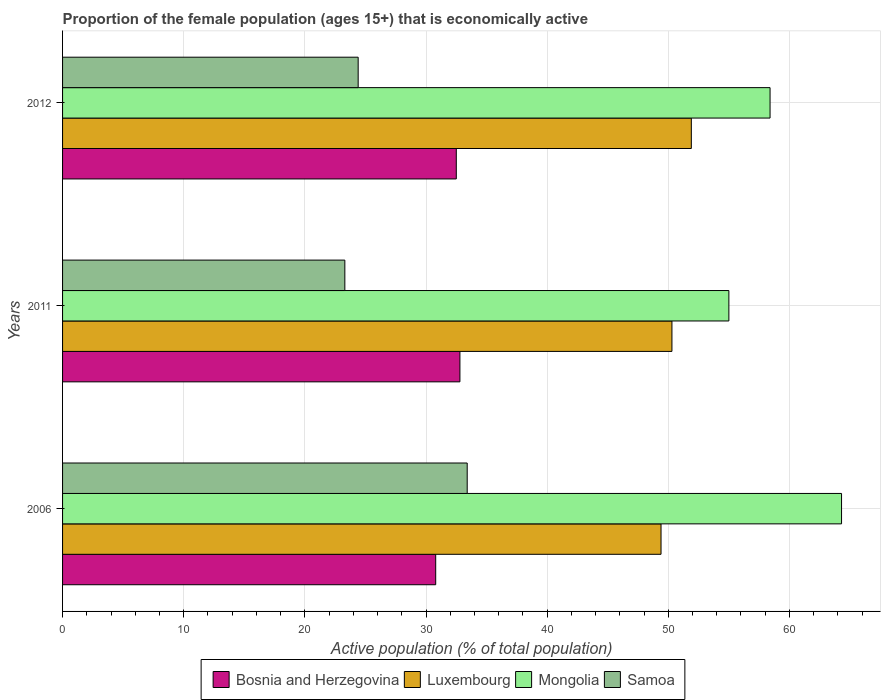How many different coloured bars are there?
Provide a short and direct response. 4. Are the number of bars per tick equal to the number of legend labels?
Your answer should be very brief. Yes. Are the number of bars on each tick of the Y-axis equal?
Keep it short and to the point. Yes. How many bars are there on the 1st tick from the bottom?
Offer a very short reply. 4. What is the label of the 3rd group of bars from the top?
Offer a terse response. 2006. What is the proportion of the female population that is economically active in Luxembourg in 2012?
Give a very brief answer. 51.9. Across all years, what is the maximum proportion of the female population that is economically active in Mongolia?
Your answer should be very brief. 64.3. Across all years, what is the minimum proportion of the female population that is economically active in Bosnia and Herzegovina?
Your answer should be very brief. 30.8. In which year was the proportion of the female population that is economically active in Samoa maximum?
Your response must be concise. 2006. What is the total proportion of the female population that is economically active in Bosnia and Herzegovina in the graph?
Your response must be concise. 96.1. What is the difference between the proportion of the female population that is economically active in Mongolia in 2006 and that in 2012?
Your answer should be compact. 5.9. What is the average proportion of the female population that is economically active in Bosnia and Herzegovina per year?
Keep it short and to the point. 32.03. In the year 2006, what is the difference between the proportion of the female population that is economically active in Samoa and proportion of the female population that is economically active in Luxembourg?
Offer a terse response. -16. What is the ratio of the proportion of the female population that is economically active in Luxembourg in 2006 to that in 2012?
Keep it short and to the point. 0.95. Is the proportion of the female population that is economically active in Bosnia and Herzegovina in 2006 less than that in 2011?
Make the answer very short. Yes. Is the difference between the proportion of the female population that is economically active in Samoa in 2011 and 2012 greater than the difference between the proportion of the female population that is economically active in Luxembourg in 2011 and 2012?
Your answer should be compact. Yes. What is the difference between the highest and the second highest proportion of the female population that is economically active in Luxembourg?
Your response must be concise. 1.6. What is the difference between the highest and the lowest proportion of the female population that is economically active in Bosnia and Herzegovina?
Keep it short and to the point. 2. What does the 1st bar from the top in 2011 represents?
Your response must be concise. Samoa. What does the 4th bar from the bottom in 2011 represents?
Offer a very short reply. Samoa. Is it the case that in every year, the sum of the proportion of the female population that is economically active in Samoa and proportion of the female population that is economically active in Luxembourg is greater than the proportion of the female population that is economically active in Bosnia and Herzegovina?
Keep it short and to the point. Yes. How many years are there in the graph?
Provide a succinct answer. 3. What is the difference between two consecutive major ticks on the X-axis?
Ensure brevity in your answer.  10. Are the values on the major ticks of X-axis written in scientific E-notation?
Offer a terse response. No. Where does the legend appear in the graph?
Offer a very short reply. Bottom center. How many legend labels are there?
Give a very brief answer. 4. How are the legend labels stacked?
Ensure brevity in your answer.  Horizontal. What is the title of the graph?
Make the answer very short. Proportion of the female population (ages 15+) that is economically active. What is the label or title of the X-axis?
Your answer should be very brief. Active population (% of total population). What is the Active population (% of total population) of Bosnia and Herzegovina in 2006?
Give a very brief answer. 30.8. What is the Active population (% of total population) of Luxembourg in 2006?
Provide a succinct answer. 49.4. What is the Active population (% of total population) in Mongolia in 2006?
Your response must be concise. 64.3. What is the Active population (% of total population) of Samoa in 2006?
Offer a very short reply. 33.4. What is the Active population (% of total population) in Bosnia and Herzegovina in 2011?
Ensure brevity in your answer.  32.8. What is the Active population (% of total population) of Luxembourg in 2011?
Your response must be concise. 50.3. What is the Active population (% of total population) in Samoa in 2011?
Provide a succinct answer. 23.3. What is the Active population (% of total population) of Bosnia and Herzegovina in 2012?
Make the answer very short. 32.5. What is the Active population (% of total population) in Luxembourg in 2012?
Give a very brief answer. 51.9. What is the Active population (% of total population) in Mongolia in 2012?
Keep it short and to the point. 58.4. What is the Active population (% of total population) of Samoa in 2012?
Keep it short and to the point. 24.4. Across all years, what is the maximum Active population (% of total population) in Bosnia and Herzegovina?
Make the answer very short. 32.8. Across all years, what is the maximum Active population (% of total population) in Luxembourg?
Offer a terse response. 51.9. Across all years, what is the maximum Active population (% of total population) in Mongolia?
Ensure brevity in your answer.  64.3. Across all years, what is the maximum Active population (% of total population) of Samoa?
Offer a terse response. 33.4. Across all years, what is the minimum Active population (% of total population) of Bosnia and Herzegovina?
Offer a very short reply. 30.8. Across all years, what is the minimum Active population (% of total population) in Luxembourg?
Provide a short and direct response. 49.4. Across all years, what is the minimum Active population (% of total population) of Mongolia?
Your answer should be very brief. 55. Across all years, what is the minimum Active population (% of total population) in Samoa?
Offer a very short reply. 23.3. What is the total Active population (% of total population) in Bosnia and Herzegovina in the graph?
Provide a short and direct response. 96.1. What is the total Active population (% of total population) in Luxembourg in the graph?
Make the answer very short. 151.6. What is the total Active population (% of total population) in Mongolia in the graph?
Give a very brief answer. 177.7. What is the total Active population (% of total population) in Samoa in the graph?
Give a very brief answer. 81.1. What is the difference between the Active population (% of total population) of Luxembourg in 2006 and that in 2011?
Keep it short and to the point. -0.9. What is the difference between the Active population (% of total population) of Mongolia in 2006 and that in 2011?
Keep it short and to the point. 9.3. What is the difference between the Active population (% of total population) of Mongolia in 2006 and that in 2012?
Give a very brief answer. 5.9. What is the difference between the Active population (% of total population) in Samoa in 2006 and that in 2012?
Offer a very short reply. 9. What is the difference between the Active population (% of total population) of Luxembourg in 2011 and that in 2012?
Your response must be concise. -1.6. What is the difference between the Active population (% of total population) in Mongolia in 2011 and that in 2012?
Keep it short and to the point. -3.4. What is the difference between the Active population (% of total population) of Samoa in 2011 and that in 2012?
Make the answer very short. -1.1. What is the difference between the Active population (% of total population) of Bosnia and Herzegovina in 2006 and the Active population (% of total population) of Luxembourg in 2011?
Your response must be concise. -19.5. What is the difference between the Active population (% of total population) of Bosnia and Herzegovina in 2006 and the Active population (% of total population) of Mongolia in 2011?
Give a very brief answer. -24.2. What is the difference between the Active population (% of total population) of Bosnia and Herzegovina in 2006 and the Active population (% of total population) of Samoa in 2011?
Provide a short and direct response. 7.5. What is the difference between the Active population (% of total population) of Luxembourg in 2006 and the Active population (% of total population) of Samoa in 2011?
Keep it short and to the point. 26.1. What is the difference between the Active population (% of total population) of Bosnia and Herzegovina in 2006 and the Active population (% of total population) of Luxembourg in 2012?
Provide a short and direct response. -21.1. What is the difference between the Active population (% of total population) in Bosnia and Herzegovina in 2006 and the Active population (% of total population) in Mongolia in 2012?
Ensure brevity in your answer.  -27.6. What is the difference between the Active population (% of total population) of Luxembourg in 2006 and the Active population (% of total population) of Mongolia in 2012?
Provide a succinct answer. -9. What is the difference between the Active population (% of total population) in Mongolia in 2006 and the Active population (% of total population) in Samoa in 2012?
Keep it short and to the point. 39.9. What is the difference between the Active population (% of total population) of Bosnia and Herzegovina in 2011 and the Active population (% of total population) of Luxembourg in 2012?
Keep it short and to the point. -19.1. What is the difference between the Active population (% of total population) in Bosnia and Herzegovina in 2011 and the Active population (% of total population) in Mongolia in 2012?
Provide a succinct answer. -25.6. What is the difference between the Active population (% of total population) in Bosnia and Herzegovina in 2011 and the Active population (% of total population) in Samoa in 2012?
Make the answer very short. 8.4. What is the difference between the Active population (% of total population) of Luxembourg in 2011 and the Active population (% of total population) of Samoa in 2012?
Your answer should be very brief. 25.9. What is the difference between the Active population (% of total population) of Mongolia in 2011 and the Active population (% of total population) of Samoa in 2012?
Provide a short and direct response. 30.6. What is the average Active population (% of total population) of Bosnia and Herzegovina per year?
Provide a short and direct response. 32.03. What is the average Active population (% of total population) in Luxembourg per year?
Provide a short and direct response. 50.53. What is the average Active population (% of total population) of Mongolia per year?
Provide a succinct answer. 59.23. What is the average Active population (% of total population) in Samoa per year?
Give a very brief answer. 27.03. In the year 2006, what is the difference between the Active population (% of total population) in Bosnia and Herzegovina and Active population (% of total population) in Luxembourg?
Make the answer very short. -18.6. In the year 2006, what is the difference between the Active population (% of total population) in Bosnia and Herzegovina and Active population (% of total population) in Mongolia?
Make the answer very short. -33.5. In the year 2006, what is the difference between the Active population (% of total population) in Bosnia and Herzegovina and Active population (% of total population) in Samoa?
Give a very brief answer. -2.6. In the year 2006, what is the difference between the Active population (% of total population) in Luxembourg and Active population (% of total population) in Mongolia?
Offer a terse response. -14.9. In the year 2006, what is the difference between the Active population (% of total population) in Luxembourg and Active population (% of total population) in Samoa?
Keep it short and to the point. 16. In the year 2006, what is the difference between the Active population (% of total population) in Mongolia and Active population (% of total population) in Samoa?
Make the answer very short. 30.9. In the year 2011, what is the difference between the Active population (% of total population) of Bosnia and Herzegovina and Active population (% of total population) of Luxembourg?
Make the answer very short. -17.5. In the year 2011, what is the difference between the Active population (% of total population) in Bosnia and Herzegovina and Active population (% of total population) in Mongolia?
Your answer should be very brief. -22.2. In the year 2011, what is the difference between the Active population (% of total population) in Luxembourg and Active population (% of total population) in Mongolia?
Ensure brevity in your answer.  -4.7. In the year 2011, what is the difference between the Active population (% of total population) in Mongolia and Active population (% of total population) in Samoa?
Offer a very short reply. 31.7. In the year 2012, what is the difference between the Active population (% of total population) of Bosnia and Herzegovina and Active population (% of total population) of Luxembourg?
Keep it short and to the point. -19.4. In the year 2012, what is the difference between the Active population (% of total population) of Bosnia and Herzegovina and Active population (% of total population) of Mongolia?
Keep it short and to the point. -25.9. In the year 2012, what is the difference between the Active population (% of total population) in Bosnia and Herzegovina and Active population (% of total population) in Samoa?
Your answer should be very brief. 8.1. In the year 2012, what is the difference between the Active population (% of total population) in Luxembourg and Active population (% of total population) in Samoa?
Give a very brief answer. 27.5. In the year 2012, what is the difference between the Active population (% of total population) of Mongolia and Active population (% of total population) of Samoa?
Offer a terse response. 34. What is the ratio of the Active population (% of total population) of Bosnia and Herzegovina in 2006 to that in 2011?
Your response must be concise. 0.94. What is the ratio of the Active population (% of total population) in Luxembourg in 2006 to that in 2011?
Your answer should be very brief. 0.98. What is the ratio of the Active population (% of total population) of Mongolia in 2006 to that in 2011?
Offer a very short reply. 1.17. What is the ratio of the Active population (% of total population) of Samoa in 2006 to that in 2011?
Provide a succinct answer. 1.43. What is the ratio of the Active population (% of total population) of Bosnia and Herzegovina in 2006 to that in 2012?
Give a very brief answer. 0.95. What is the ratio of the Active population (% of total population) in Luxembourg in 2006 to that in 2012?
Offer a terse response. 0.95. What is the ratio of the Active population (% of total population) of Mongolia in 2006 to that in 2012?
Keep it short and to the point. 1.1. What is the ratio of the Active population (% of total population) in Samoa in 2006 to that in 2012?
Offer a very short reply. 1.37. What is the ratio of the Active population (% of total population) in Bosnia and Herzegovina in 2011 to that in 2012?
Your response must be concise. 1.01. What is the ratio of the Active population (% of total population) in Luxembourg in 2011 to that in 2012?
Offer a terse response. 0.97. What is the ratio of the Active population (% of total population) of Mongolia in 2011 to that in 2012?
Provide a short and direct response. 0.94. What is the ratio of the Active population (% of total population) of Samoa in 2011 to that in 2012?
Offer a terse response. 0.95. What is the difference between the highest and the second highest Active population (% of total population) in Bosnia and Herzegovina?
Your response must be concise. 0.3. What is the difference between the highest and the second highest Active population (% of total population) of Luxembourg?
Give a very brief answer. 1.6. What is the difference between the highest and the lowest Active population (% of total population) in Luxembourg?
Keep it short and to the point. 2.5. What is the difference between the highest and the lowest Active population (% of total population) of Mongolia?
Provide a succinct answer. 9.3. 